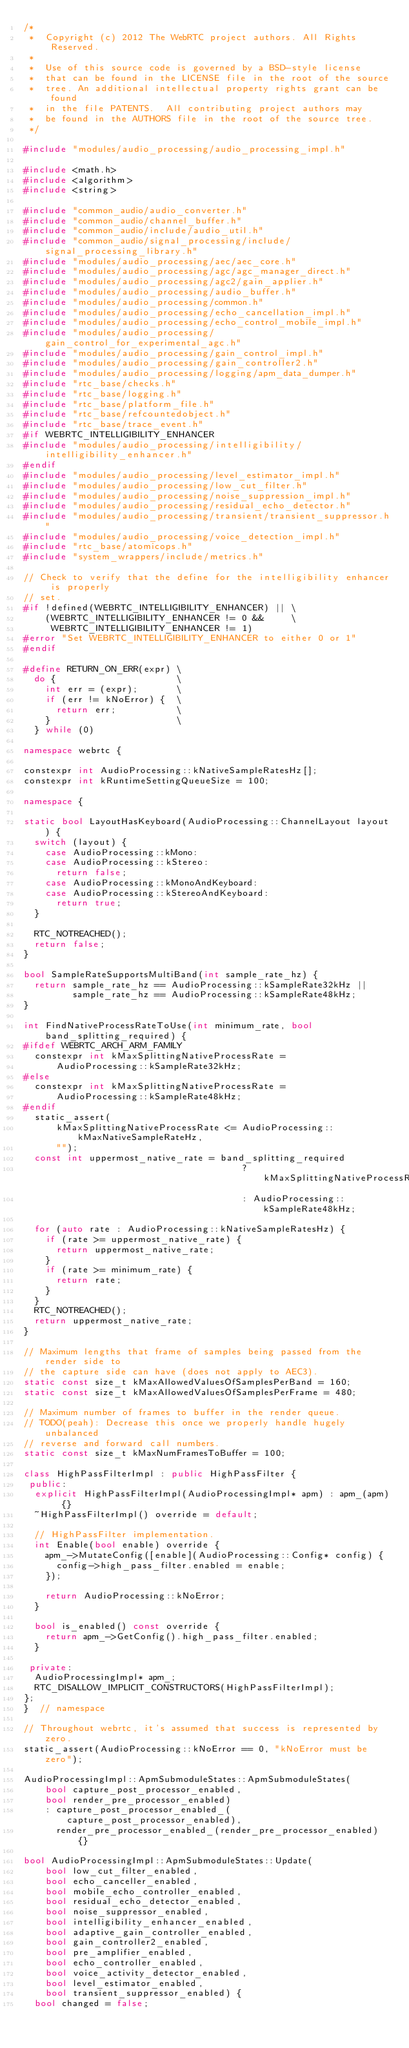Convert code to text. <code><loc_0><loc_0><loc_500><loc_500><_C++_>/*
 *  Copyright (c) 2012 The WebRTC project authors. All Rights Reserved.
 *
 *  Use of this source code is governed by a BSD-style license
 *  that can be found in the LICENSE file in the root of the source
 *  tree. An additional intellectual property rights grant can be found
 *  in the file PATENTS.  All contributing project authors may
 *  be found in the AUTHORS file in the root of the source tree.
 */

#include "modules/audio_processing/audio_processing_impl.h"

#include <math.h>
#include <algorithm>
#include <string>

#include "common_audio/audio_converter.h"
#include "common_audio/channel_buffer.h"
#include "common_audio/include/audio_util.h"
#include "common_audio/signal_processing/include/signal_processing_library.h"
#include "modules/audio_processing/aec/aec_core.h"
#include "modules/audio_processing/agc/agc_manager_direct.h"
#include "modules/audio_processing/agc2/gain_applier.h"
#include "modules/audio_processing/audio_buffer.h"
#include "modules/audio_processing/common.h"
#include "modules/audio_processing/echo_cancellation_impl.h"
#include "modules/audio_processing/echo_control_mobile_impl.h"
#include "modules/audio_processing/gain_control_for_experimental_agc.h"
#include "modules/audio_processing/gain_control_impl.h"
#include "modules/audio_processing/gain_controller2.h"
#include "modules/audio_processing/logging/apm_data_dumper.h"
#include "rtc_base/checks.h"
#include "rtc_base/logging.h"
#include "rtc_base/platform_file.h"
#include "rtc_base/refcountedobject.h"
#include "rtc_base/trace_event.h"
#if WEBRTC_INTELLIGIBILITY_ENHANCER
#include "modules/audio_processing/intelligibility/intelligibility_enhancer.h"
#endif
#include "modules/audio_processing/level_estimator_impl.h"
#include "modules/audio_processing/low_cut_filter.h"
#include "modules/audio_processing/noise_suppression_impl.h"
#include "modules/audio_processing/residual_echo_detector.h"
#include "modules/audio_processing/transient/transient_suppressor.h"
#include "modules/audio_processing/voice_detection_impl.h"
#include "rtc_base/atomicops.h"
#include "system_wrappers/include/metrics.h"

// Check to verify that the define for the intelligibility enhancer is properly
// set.
#if !defined(WEBRTC_INTELLIGIBILITY_ENHANCER) || \
    (WEBRTC_INTELLIGIBILITY_ENHANCER != 0 &&     \
     WEBRTC_INTELLIGIBILITY_ENHANCER != 1)
#error "Set WEBRTC_INTELLIGIBILITY_ENHANCER to either 0 or 1"
#endif

#define RETURN_ON_ERR(expr) \
  do {                      \
    int err = (expr);       \
    if (err != kNoError) {  \
      return err;           \
    }                       \
  } while (0)

namespace webrtc {

constexpr int AudioProcessing::kNativeSampleRatesHz[];
constexpr int kRuntimeSettingQueueSize = 100;

namespace {

static bool LayoutHasKeyboard(AudioProcessing::ChannelLayout layout) {
  switch (layout) {
    case AudioProcessing::kMono:
    case AudioProcessing::kStereo:
      return false;
    case AudioProcessing::kMonoAndKeyboard:
    case AudioProcessing::kStereoAndKeyboard:
      return true;
  }

  RTC_NOTREACHED();
  return false;
}

bool SampleRateSupportsMultiBand(int sample_rate_hz) {
  return sample_rate_hz == AudioProcessing::kSampleRate32kHz ||
         sample_rate_hz == AudioProcessing::kSampleRate48kHz;
}

int FindNativeProcessRateToUse(int minimum_rate, bool band_splitting_required) {
#ifdef WEBRTC_ARCH_ARM_FAMILY
  constexpr int kMaxSplittingNativeProcessRate =
      AudioProcessing::kSampleRate32kHz;
#else
  constexpr int kMaxSplittingNativeProcessRate =
      AudioProcessing::kSampleRate48kHz;
#endif
  static_assert(
      kMaxSplittingNativeProcessRate <= AudioProcessing::kMaxNativeSampleRateHz,
      "");
  const int uppermost_native_rate = band_splitting_required
                                        ? kMaxSplittingNativeProcessRate
                                        : AudioProcessing::kSampleRate48kHz;

  for (auto rate : AudioProcessing::kNativeSampleRatesHz) {
    if (rate >= uppermost_native_rate) {
      return uppermost_native_rate;
    }
    if (rate >= minimum_rate) {
      return rate;
    }
  }
  RTC_NOTREACHED();
  return uppermost_native_rate;
}

// Maximum lengths that frame of samples being passed from the render side to
// the capture side can have (does not apply to AEC3).
static const size_t kMaxAllowedValuesOfSamplesPerBand = 160;
static const size_t kMaxAllowedValuesOfSamplesPerFrame = 480;

// Maximum number of frames to buffer in the render queue.
// TODO(peah): Decrease this once we properly handle hugely unbalanced
// reverse and forward call numbers.
static const size_t kMaxNumFramesToBuffer = 100;

class HighPassFilterImpl : public HighPassFilter {
 public:
  explicit HighPassFilterImpl(AudioProcessingImpl* apm) : apm_(apm) {}
  ~HighPassFilterImpl() override = default;

  // HighPassFilter implementation.
  int Enable(bool enable) override {
    apm_->MutateConfig([enable](AudioProcessing::Config* config) {
      config->high_pass_filter.enabled = enable;
    });

    return AudioProcessing::kNoError;
  }

  bool is_enabled() const override {
    return apm_->GetConfig().high_pass_filter.enabled;
  }

 private:
  AudioProcessingImpl* apm_;
  RTC_DISALLOW_IMPLICIT_CONSTRUCTORS(HighPassFilterImpl);
};
}  // namespace

// Throughout webrtc, it's assumed that success is represented by zero.
static_assert(AudioProcessing::kNoError == 0, "kNoError must be zero");

AudioProcessingImpl::ApmSubmoduleStates::ApmSubmoduleStates(
    bool capture_post_processor_enabled,
    bool render_pre_processor_enabled)
    : capture_post_processor_enabled_(capture_post_processor_enabled),
      render_pre_processor_enabled_(render_pre_processor_enabled) {}

bool AudioProcessingImpl::ApmSubmoduleStates::Update(
    bool low_cut_filter_enabled,
    bool echo_canceller_enabled,
    bool mobile_echo_controller_enabled,
    bool residual_echo_detector_enabled,
    bool noise_suppressor_enabled,
    bool intelligibility_enhancer_enabled,
    bool adaptive_gain_controller_enabled,
    bool gain_controller2_enabled,
    bool pre_amplifier_enabled,
    bool echo_controller_enabled,
    bool voice_activity_detector_enabled,
    bool level_estimator_enabled,
    bool transient_suppressor_enabled) {
  bool changed = false;</code> 